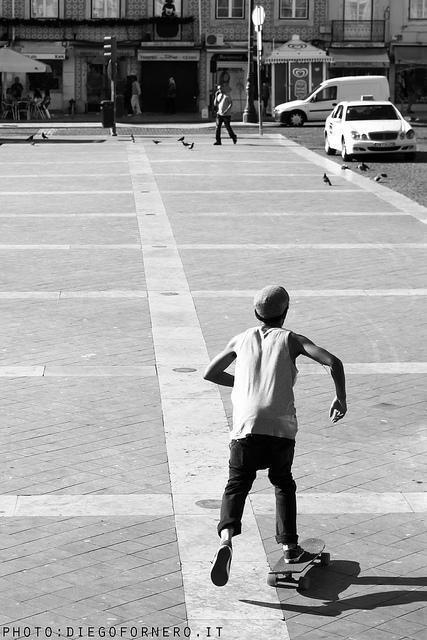What kind of refined natural resource is used to power the white car?
Pick the right solution, then justify: 'Answer: answer
Rationale: rationale.'
Options: Jet fuel, gasoline, corn alcohol, diesel fuel. Answer: gasoline.
Rationale: An automobile is driving in the street. 